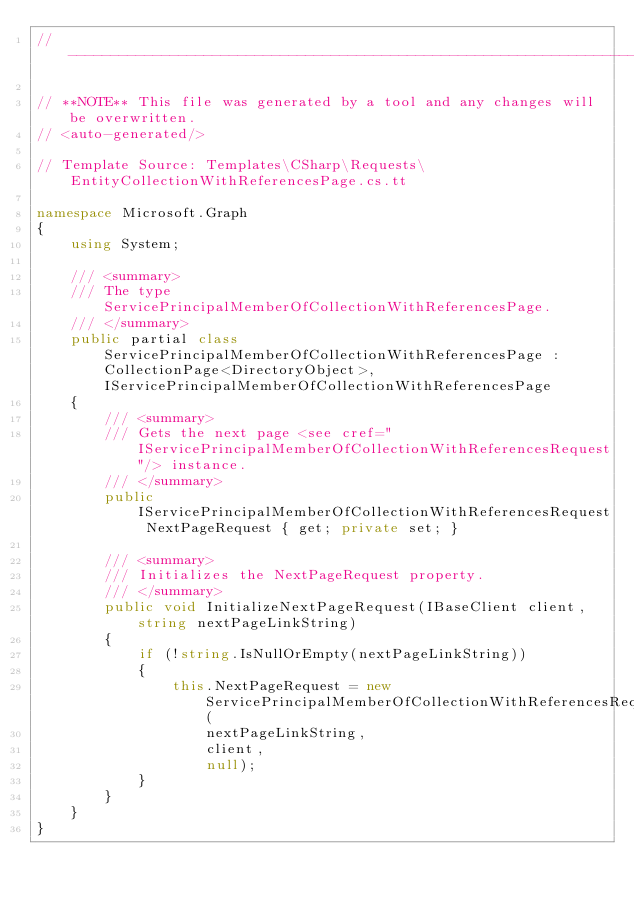<code> <loc_0><loc_0><loc_500><loc_500><_C#_>// ------------------------------------------------------------------------------

// **NOTE** This file was generated by a tool and any changes will be overwritten.
// <auto-generated/>

// Template Source: Templates\CSharp\Requests\EntityCollectionWithReferencesPage.cs.tt

namespace Microsoft.Graph
{
    using System;

    /// <summary>
    /// The type ServicePrincipalMemberOfCollectionWithReferencesPage.
    /// </summary>
    public partial class ServicePrincipalMemberOfCollectionWithReferencesPage : CollectionPage<DirectoryObject>, IServicePrincipalMemberOfCollectionWithReferencesPage
    {
        /// <summary>
        /// Gets the next page <see cref="IServicePrincipalMemberOfCollectionWithReferencesRequest"/> instance.
        /// </summary>
        public IServicePrincipalMemberOfCollectionWithReferencesRequest NextPageRequest { get; private set; }

        /// <summary>
        /// Initializes the NextPageRequest property.
        /// </summary>
        public void InitializeNextPageRequest(IBaseClient client, string nextPageLinkString)
        {
            if (!string.IsNullOrEmpty(nextPageLinkString))
            {
                this.NextPageRequest = new ServicePrincipalMemberOfCollectionWithReferencesRequest(
                    nextPageLinkString,
                    client,
                    null);
            }
        }
    }
}
</code> 